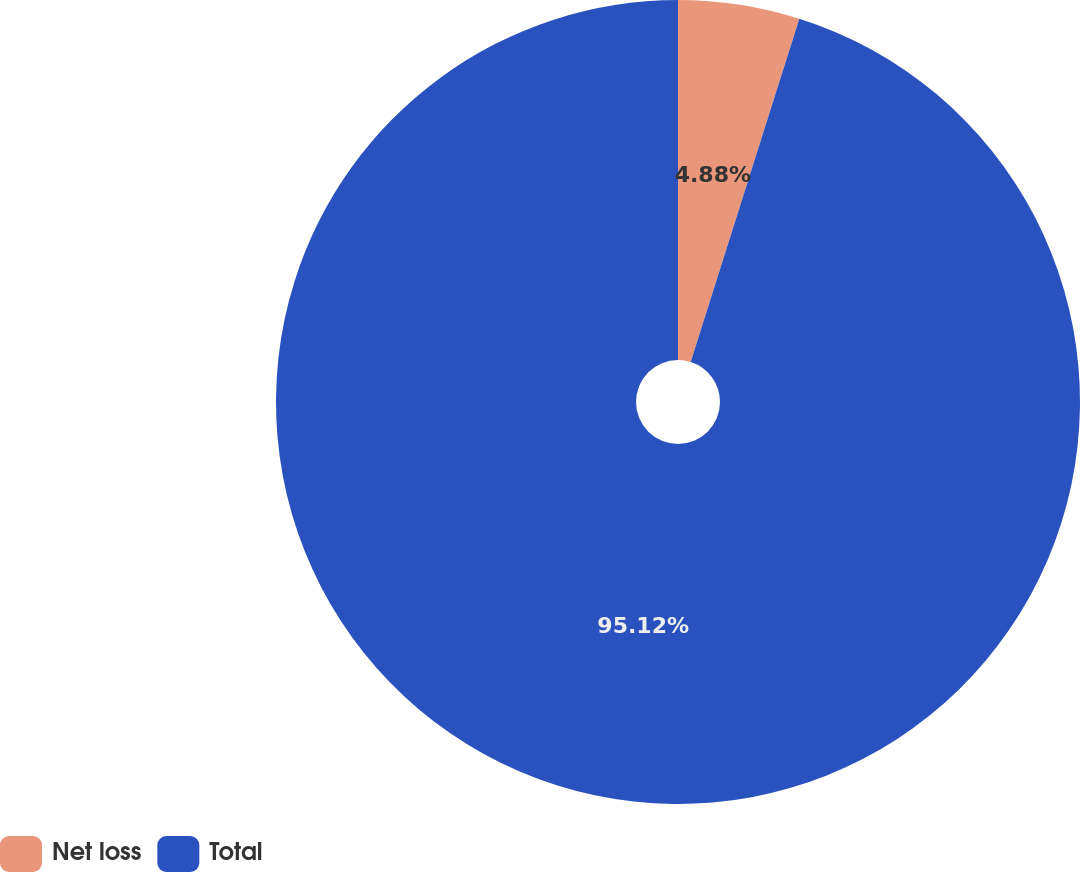<chart> <loc_0><loc_0><loc_500><loc_500><pie_chart><fcel>Net loss<fcel>Total<nl><fcel>4.88%<fcel>95.12%<nl></chart> 